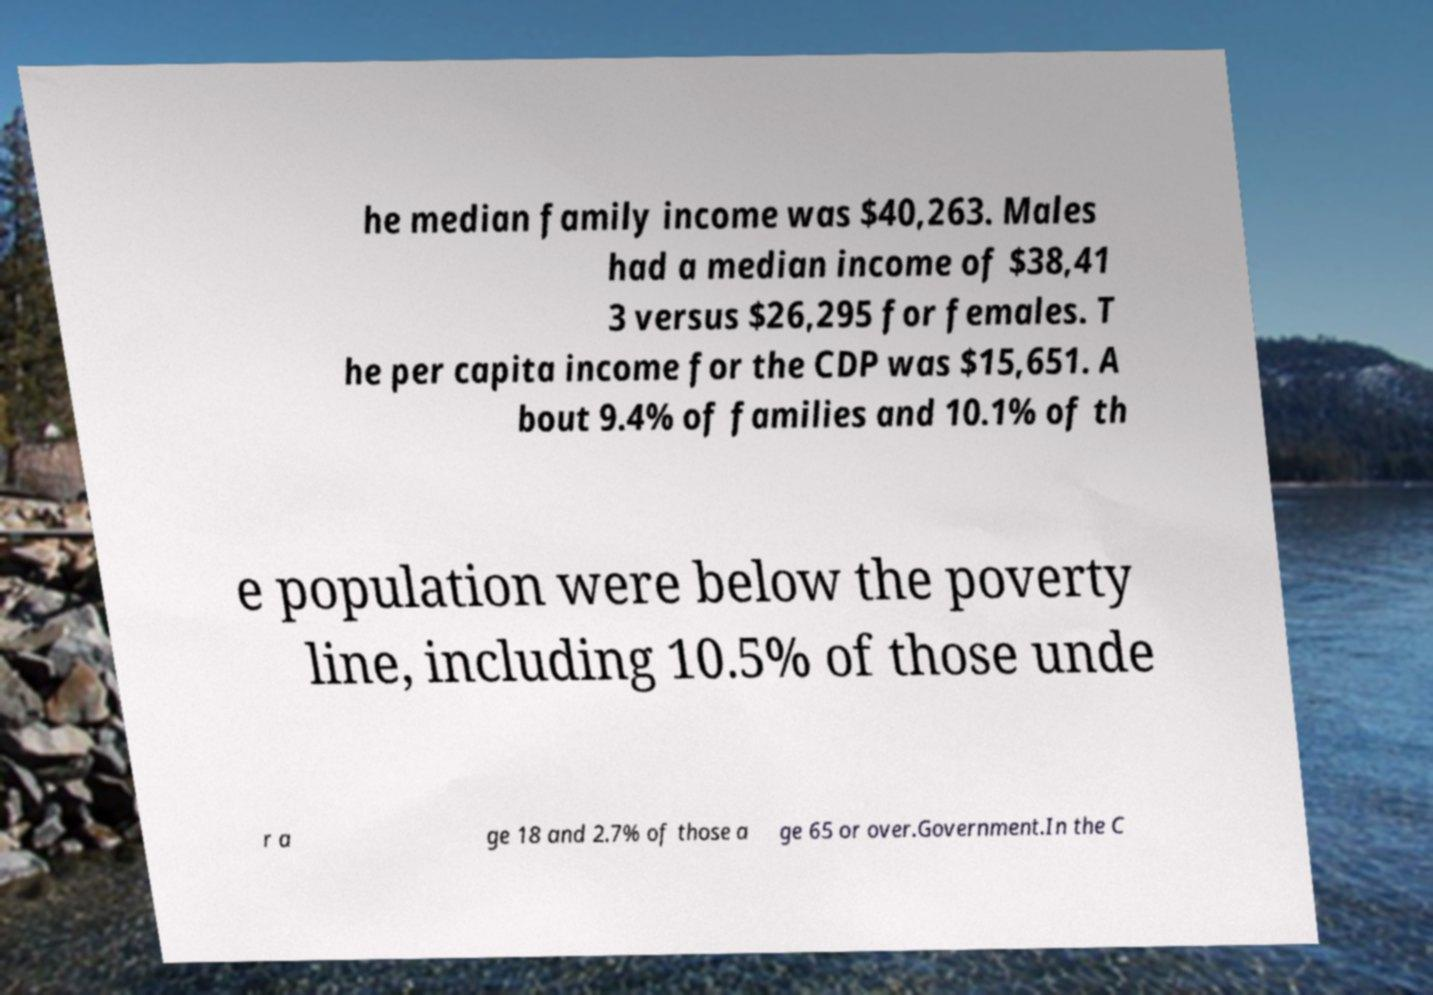Please identify and transcribe the text found in this image. he median family income was $40,263. Males had a median income of $38,41 3 versus $26,295 for females. T he per capita income for the CDP was $15,651. A bout 9.4% of families and 10.1% of th e population were below the poverty line, including 10.5% of those unde r a ge 18 and 2.7% of those a ge 65 or over.Government.In the C 